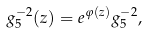<formula> <loc_0><loc_0><loc_500><loc_500>g ^ { - 2 } _ { 5 } ( z ) = e ^ { \varphi ( z ) } g ^ { - 2 } _ { 5 } ,</formula> 